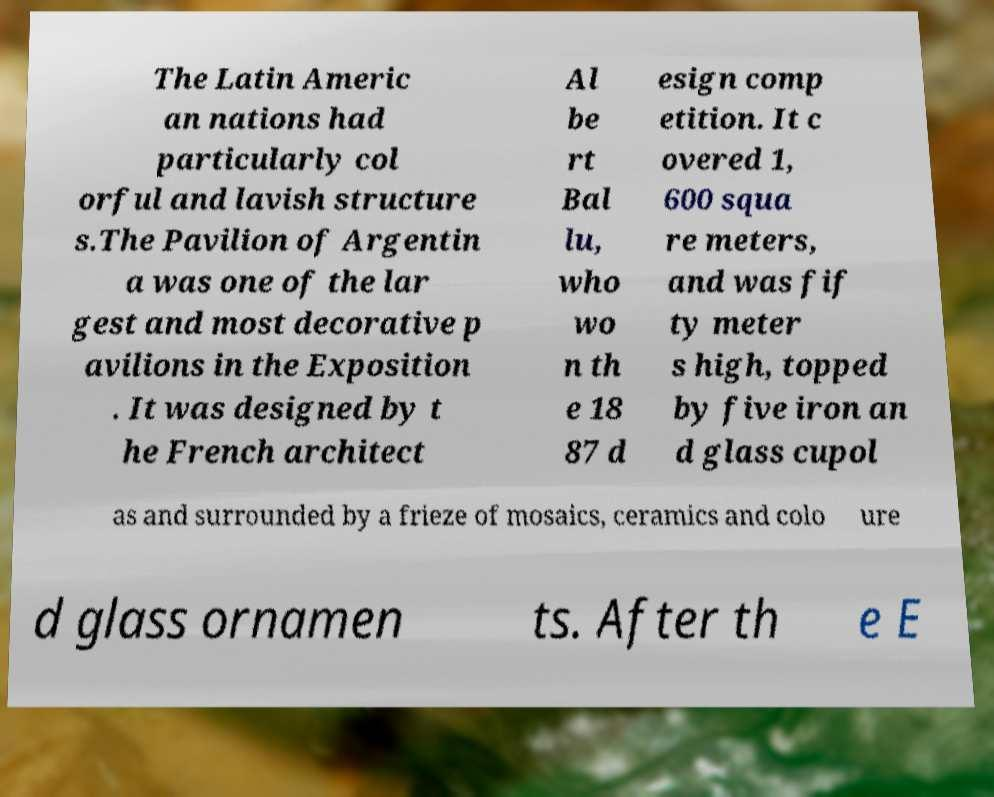Please identify and transcribe the text found in this image. The Latin Americ an nations had particularly col orful and lavish structure s.The Pavilion of Argentin a was one of the lar gest and most decorative p avilions in the Exposition . It was designed by t he French architect Al be rt Bal lu, who wo n th e 18 87 d esign comp etition. It c overed 1, 600 squa re meters, and was fif ty meter s high, topped by five iron an d glass cupol as and surrounded by a frieze of mosaics, ceramics and colo ure d glass ornamen ts. After th e E 